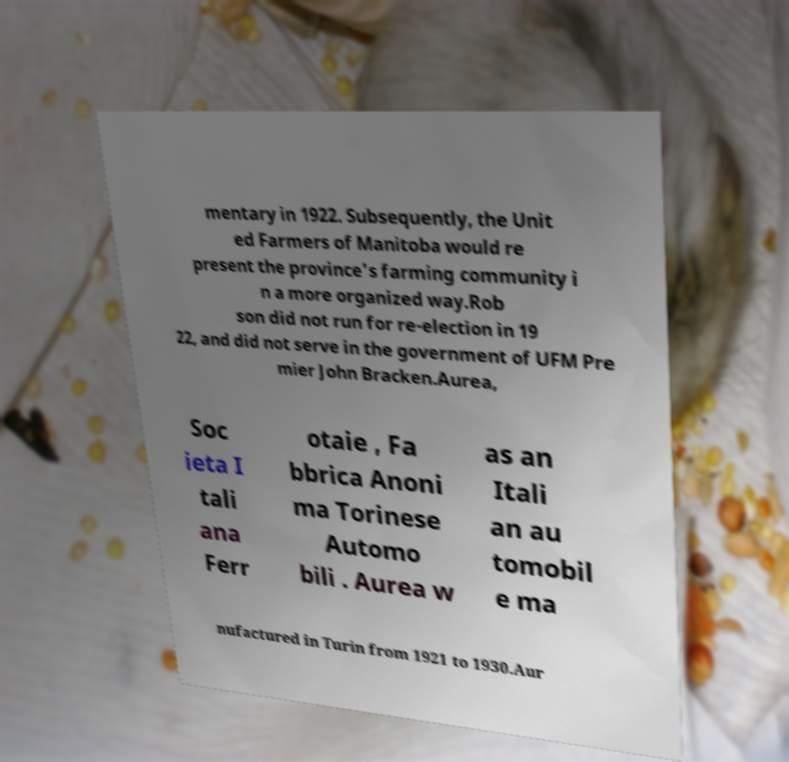Could you extract and type out the text from this image? mentary in 1922. Subsequently, the Unit ed Farmers of Manitoba would re present the province's farming community i n a more organized way.Rob son did not run for re-election in 19 22, and did not serve in the government of UFM Pre mier John Bracken.Aurea, Soc ieta I tali ana Ferr otaie , Fa bbrica Anoni ma Torinese Automo bili . Aurea w as an Itali an au tomobil e ma nufactured in Turin from 1921 to 1930.Aur 